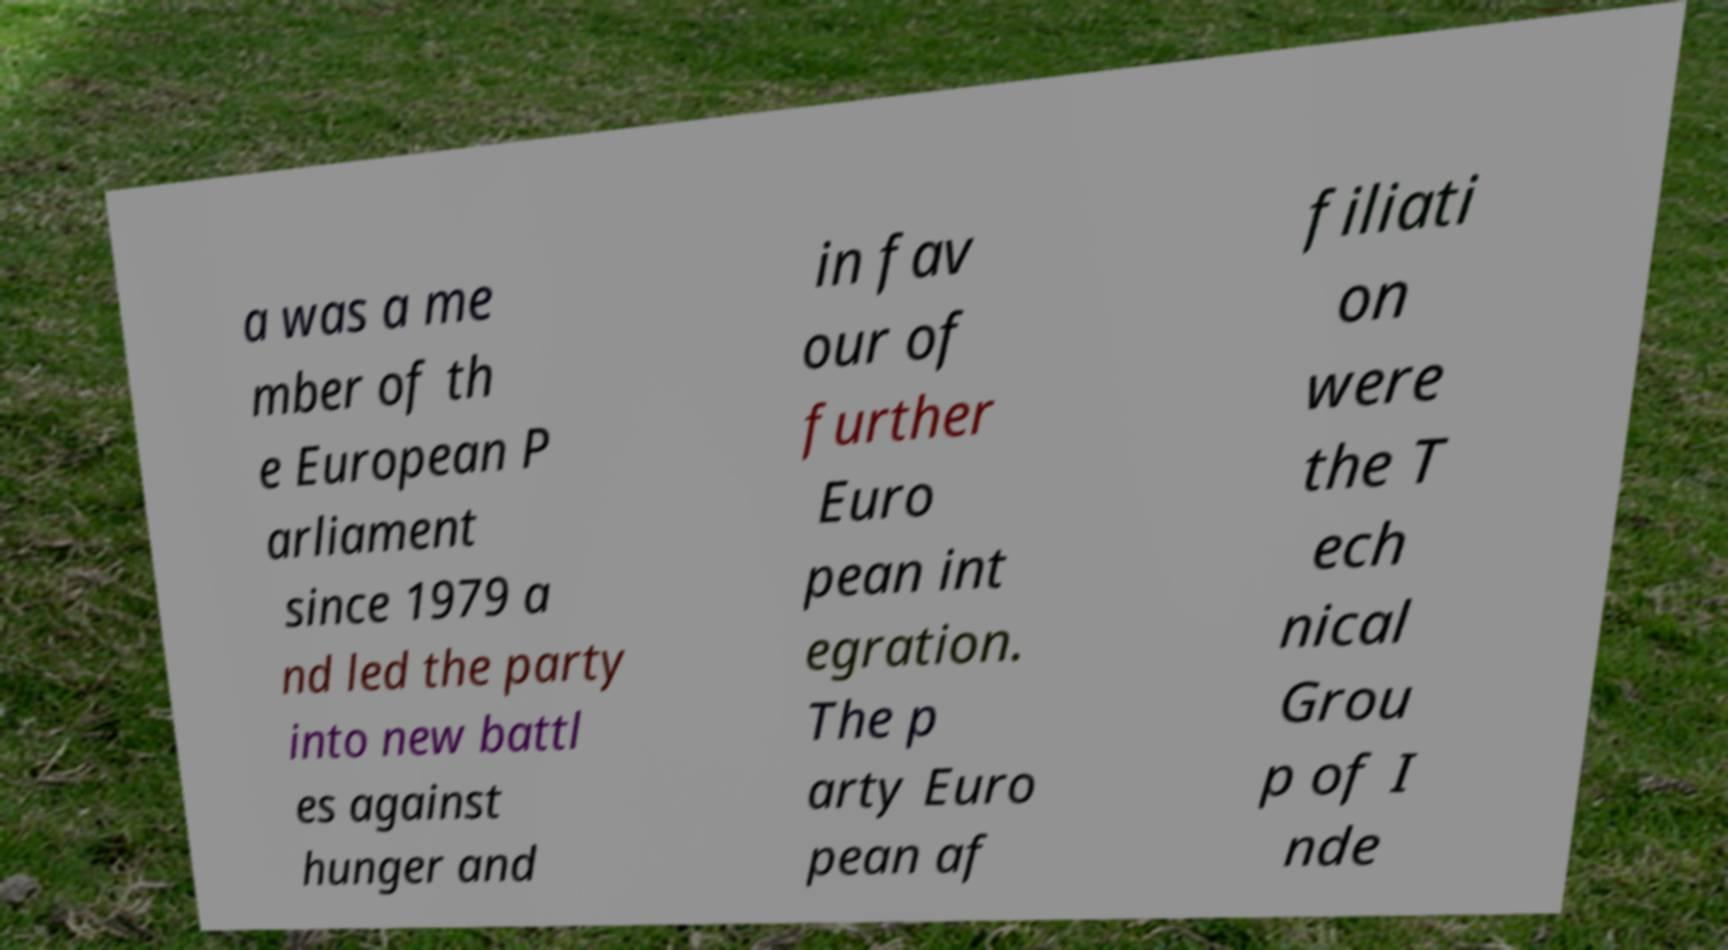Please read and relay the text visible in this image. What does it say? a was a me mber of th e European P arliament since 1979 a nd led the party into new battl es against hunger and in fav our of further Euro pean int egration. The p arty Euro pean af filiati on were the T ech nical Grou p of I nde 